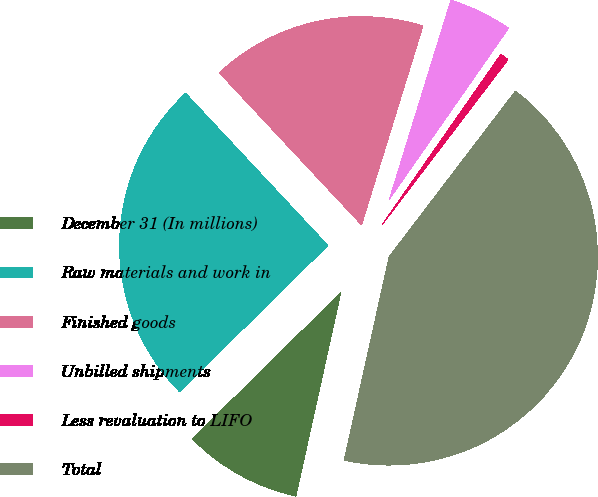<chart> <loc_0><loc_0><loc_500><loc_500><pie_chart><fcel>December 31 (In millions)<fcel>Raw materials and work in<fcel>Finished goods<fcel>Unbilled shipments<fcel>Less revaluation to LIFO<fcel>Total<nl><fcel>9.16%<fcel>25.42%<fcel>16.73%<fcel>4.92%<fcel>0.68%<fcel>43.09%<nl></chart> 